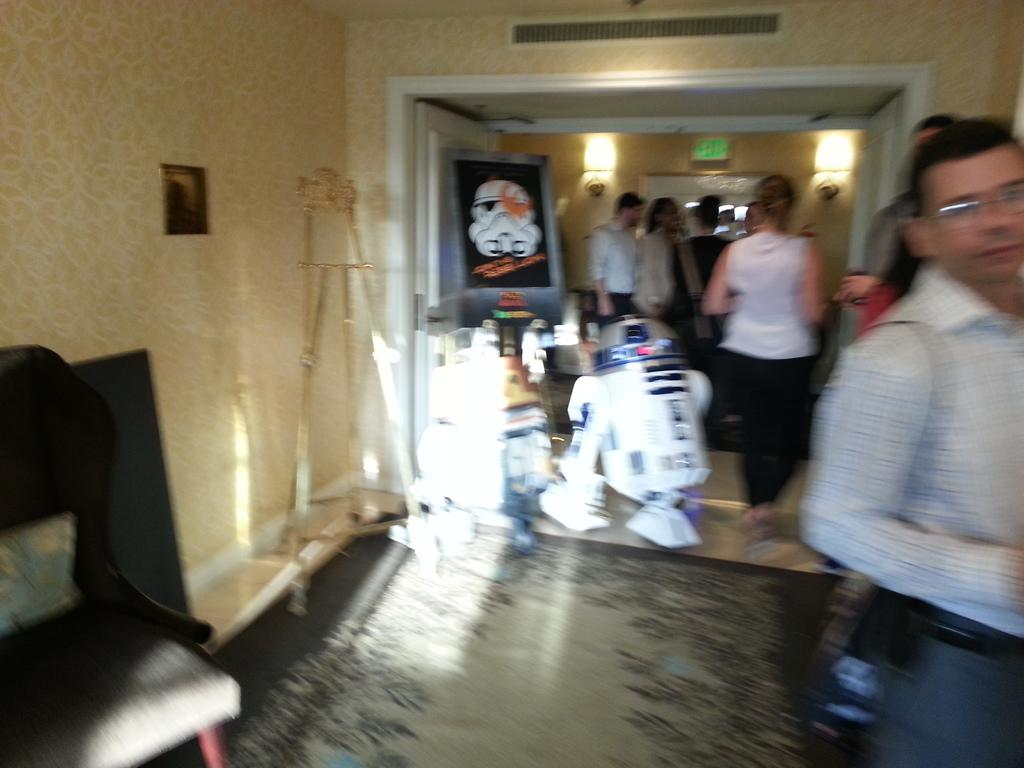Who or what is present in the image? There are people in the image. What type of furniture can be seen in the image? There is a chair in the image. What color can be observed among the objects in the image? There are white color objects in the image. What is on the floor in the image? There are objects on the floor in the image. What color is the wall in the image? The wall is in cream color. How is the wall depicted in the image? The wall is blurred. What type of coil is being used by the people in the image? There is no coil present in the image. What is the plot of the story being depicted in the image? The image does not depict a story, so there is no plot to describe. 